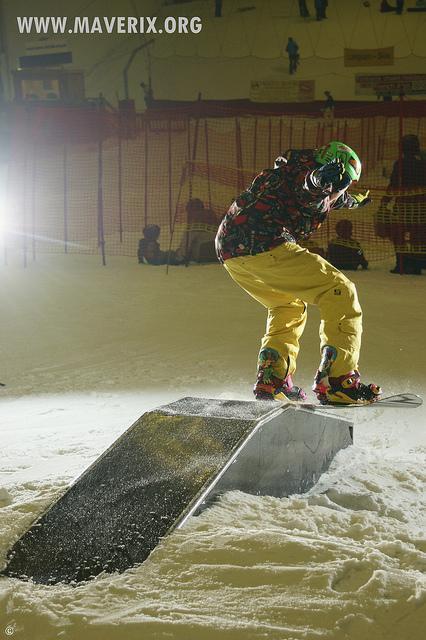How many people are there?
Give a very brief answer. 3. 